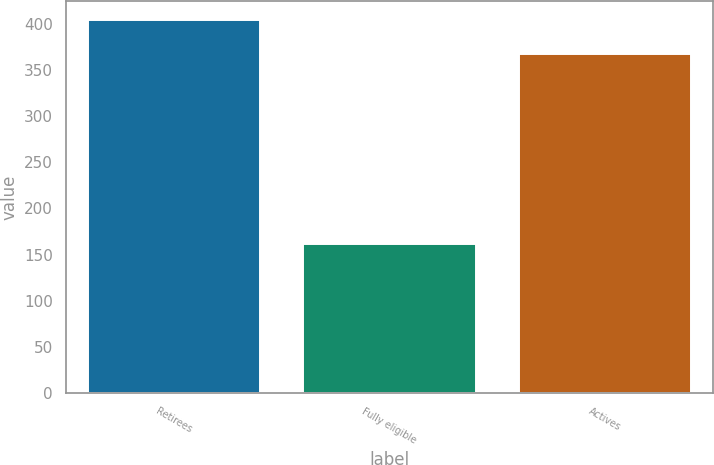<chart> <loc_0><loc_0><loc_500><loc_500><bar_chart><fcel>Retirees<fcel>Fully eligible<fcel>Actives<nl><fcel>404<fcel>162<fcel>367<nl></chart> 